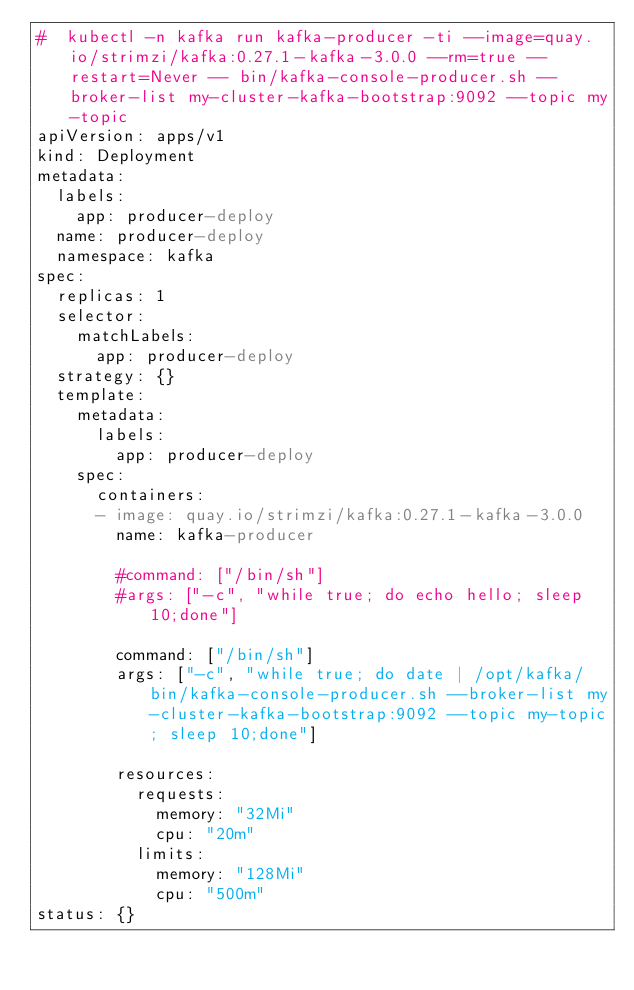<code> <loc_0><loc_0><loc_500><loc_500><_YAML_>#  kubectl -n kafka run kafka-producer -ti --image=quay.io/strimzi/kafka:0.27.1-kafka-3.0.0 --rm=true --restart=Never -- bin/kafka-console-producer.sh --broker-list my-cluster-kafka-bootstrap:9092 --topic my-topic
apiVersion: apps/v1
kind: Deployment
metadata:
  labels:
    app: producer-deploy
  name: producer-deploy
  namespace: kafka
spec:
  replicas: 1
  selector:
    matchLabels:
      app: producer-deploy
  strategy: {}
  template:
    metadata:
      labels:
        app: producer-deploy
    spec:
      containers:
      - image: quay.io/strimzi/kafka:0.27.1-kafka-3.0.0
        name: kafka-producer

        #command: ["/bin/sh"]
        #args: ["-c", "while true; do echo hello; sleep 10;done"]
      
        command: ["/bin/sh"]
        args: ["-c", "while true; do date | /opt/kafka/bin/kafka-console-producer.sh --broker-list my-cluster-kafka-bootstrap:9092 --topic my-topic; sleep 10;done"]

        resources:
          requests:
            memory: "32Mi"
            cpu: "20m"
          limits:
            memory: "128Mi"
            cpu: "500m"
status: {}

</code> 